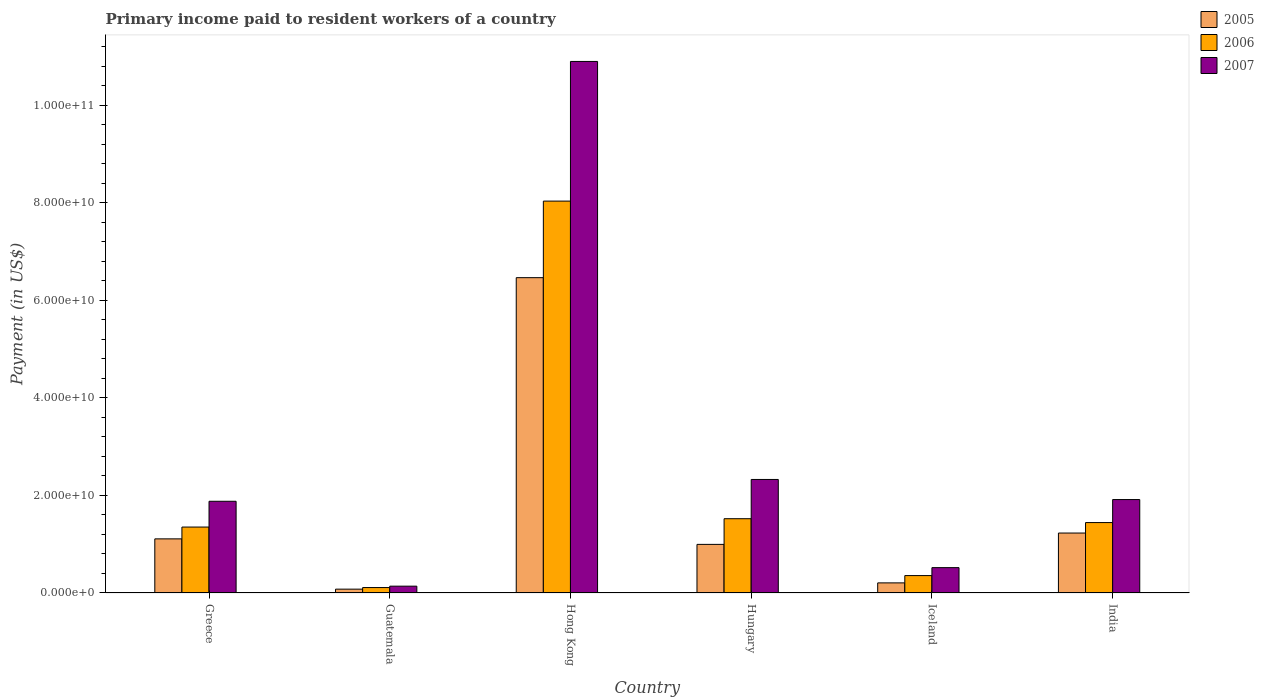How many different coloured bars are there?
Make the answer very short. 3. Are the number of bars on each tick of the X-axis equal?
Provide a succinct answer. Yes. What is the label of the 5th group of bars from the left?
Make the answer very short. Iceland. In how many cases, is the number of bars for a given country not equal to the number of legend labels?
Provide a succinct answer. 0. What is the amount paid to workers in 2006 in Guatemala?
Offer a very short reply. 1.12e+09. Across all countries, what is the maximum amount paid to workers in 2007?
Ensure brevity in your answer.  1.09e+11. Across all countries, what is the minimum amount paid to workers in 2005?
Provide a succinct answer. 7.86e+08. In which country was the amount paid to workers in 2005 maximum?
Give a very brief answer. Hong Kong. In which country was the amount paid to workers in 2005 minimum?
Offer a terse response. Guatemala. What is the total amount paid to workers in 2007 in the graph?
Your response must be concise. 1.77e+11. What is the difference between the amount paid to workers in 2007 in Greece and that in Hong Kong?
Your answer should be compact. -9.02e+1. What is the difference between the amount paid to workers in 2005 in Iceland and the amount paid to workers in 2007 in Greece?
Offer a terse response. -1.67e+1. What is the average amount paid to workers in 2007 per country?
Your response must be concise. 2.95e+1. What is the difference between the amount paid to workers of/in 2007 and amount paid to workers of/in 2005 in Guatemala?
Keep it short and to the point. 6.12e+08. What is the ratio of the amount paid to workers in 2007 in Guatemala to that in India?
Keep it short and to the point. 0.07. Is the amount paid to workers in 2006 in Guatemala less than that in Iceland?
Your answer should be very brief. Yes. Is the difference between the amount paid to workers in 2007 in Hong Kong and Hungary greater than the difference between the amount paid to workers in 2005 in Hong Kong and Hungary?
Provide a succinct answer. Yes. What is the difference between the highest and the second highest amount paid to workers in 2005?
Give a very brief answer. 5.36e+1. What is the difference between the highest and the lowest amount paid to workers in 2006?
Give a very brief answer. 7.93e+1. How many bars are there?
Your answer should be very brief. 18. How many countries are there in the graph?
Your answer should be very brief. 6. Does the graph contain any zero values?
Provide a succinct answer. No. Does the graph contain grids?
Your response must be concise. No. How are the legend labels stacked?
Make the answer very short. Vertical. What is the title of the graph?
Provide a succinct answer. Primary income paid to resident workers of a country. What is the label or title of the X-axis?
Offer a terse response. Country. What is the label or title of the Y-axis?
Keep it short and to the point. Payment (in US$). What is the Payment (in US$) in 2005 in Greece?
Keep it short and to the point. 1.11e+1. What is the Payment (in US$) in 2006 in Greece?
Your answer should be compact. 1.35e+1. What is the Payment (in US$) in 2007 in Greece?
Provide a short and direct response. 1.88e+1. What is the Payment (in US$) of 2005 in Guatemala?
Offer a terse response. 7.86e+08. What is the Payment (in US$) in 2006 in Guatemala?
Keep it short and to the point. 1.12e+09. What is the Payment (in US$) in 2007 in Guatemala?
Your response must be concise. 1.40e+09. What is the Payment (in US$) of 2005 in Hong Kong?
Provide a succinct answer. 6.47e+1. What is the Payment (in US$) of 2006 in Hong Kong?
Give a very brief answer. 8.04e+1. What is the Payment (in US$) in 2007 in Hong Kong?
Your answer should be compact. 1.09e+11. What is the Payment (in US$) in 2005 in Hungary?
Offer a very short reply. 9.97e+09. What is the Payment (in US$) of 2006 in Hungary?
Your response must be concise. 1.52e+1. What is the Payment (in US$) of 2007 in Hungary?
Give a very brief answer. 2.33e+1. What is the Payment (in US$) in 2005 in Iceland?
Your answer should be compact. 2.07e+09. What is the Payment (in US$) of 2006 in Iceland?
Provide a succinct answer. 3.57e+09. What is the Payment (in US$) in 2007 in Iceland?
Your response must be concise. 5.20e+09. What is the Payment (in US$) of 2005 in India?
Provide a short and direct response. 1.23e+1. What is the Payment (in US$) in 2006 in India?
Make the answer very short. 1.44e+1. What is the Payment (in US$) in 2007 in India?
Your answer should be compact. 1.92e+1. Across all countries, what is the maximum Payment (in US$) in 2005?
Your answer should be compact. 6.47e+1. Across all countries, what is the maximum Payment (in US$) in 2006?
Your answer should be compact. 8.04e+1. Across all countries, what is the maximum Payment (in US$) in 2007?
Give a very brief answer. 1.09e+11. Across all countries, what is the minimum Payment (in US$) of 2005?
Make the answer very short. 7.86e+08. Across all countries, what is the minimum Payment (in US$) of 2006?
Provide a short and direct response. 1.12e+09. Across all countries, what is the minimum Payment (in US$) in 2007?
Give a very brief answer. 1.40e+09. What is the total Payment (in US$) in 2005 in the graph?
Your answer should be compact. 1.01e+11. What is the total Payment (in US$) in 2006 in the graph?
Give a very brief answer. 1.28e+11. What is the total Payment (in US$) of 2007 in the graph?
Your answer should be compact. 1.77e+11. What is the difference between the Payment (in US$) in 2005 in Greece and that in Guatemala?
Your answer should be compact. 1.03e+1. What is the difference between the Payment (in US$) in 2006 in Greece and that in Guatemala?
Your answer should be compact. 1.24e+1. What is the difference between the Payment (in US$) in 2007 in Greece and that in Guatemala?
Offer a terse response. 1.74e+1. What is the difference between the Payment (in US$) of 2005 in Greece and that in Hong Kong?
Make the answer very short. -5.36e+1. What is the difference between the Payment (in US$) of 2006 in Greece and that in Hong Kong?
Provide a succinct answer. -6.69e+1. What is the difference between the Payment (in US$) of 2007 in Greece and that in Hong Kong?
Your answer should be compact. -9.02e+1. What is the difference between the Payment (in US$) in 2005 in Greece and that in Hungary?
Keep it short and to the point. 1.13e+09. What is the difference between the Payment (in US$) of 2006 in Greece and that in Hungary?
Offer a very short reply. -1.71e+09. What is the difference between the Payment (in US$) of 2007 in Greece and that in Hungary?
Your answer should be compact. -4.47e+09. What is the difference between the Payment (in US$) of 2005 in Greece and that in Iceland?
Your answer should be very brief. 9.03e+09. What is the difference between the Payment (in US$) in 2006 in Greece and that in Iceland?
Give a very brief answer. 9.95e+09. What is the difference between the Payment (in US$) in 2007 in Greece and that in Iceland?
Provide a short and direct response. 1.36e+1. What is the difference between the Payment (in US$) in 2005 in Greece and that in India?
Provide a short and direct response. -1.19e+09. What is the difference between the Payment (in US$) in 2006 in Greece and that in India?
Your response must be concise. -9.21e+08. What is the difference between the Payment (in US$) in 2007 in Greece and that in India?
Provide a succinct answer. -3.52e+08. What is the difference between the Payment (in US$) of 2005 in Guatemala and that in Hong Kong?
Your response must be concise. -6.39e+1. What is the difference between the Payment (in US$) of 2006 in Guatemala and that in Hong Kong?
Your answer should be compact. -7.93e+1. What is the difference between the Payment (in US$) in 2007 in Guatemala and that in Hong Kong?
Your response must be concise. -1.08e+11. What is the difference between the Payment (in US$) of 2005 in Guatemala and that in Hungary?
Keep it short and to the point. -9.18e+09. What is the difference between the Payment (in US$) in 2006 in Guatemala and that in Hungary?
Provide a succinct answer. -1.41e+1. What is the difference between the Payment (in US$) in 2007 in Guatemala and that in Hungary?
Offer a very short reply. -2.19e+1. What is the difference between the Payment (in US$) in 2005 in Guatemala and that in Iceland?
Your answer should be compact. -1.29e+09. What is the difference between the Payment (in US$) of 2006 in Guatemala and that in Iceland?
Your answer should be compact. -2.45e+09. What is the difference between the Payment (in US$) in 2007 in Guatemala and that in Iceland?
Your answer should be very brief. -3.80e+09. What is the difference between the Payment (in US$) in 2005 in Guatemala and that in India?
Keep it short and to the point. -1.15e+1. What is the difference between the Payment (in US$) in 2006 in Guatemala and that in India?
Your answer should be very brief. -1.33e+1. What is the difference between the Payment (in US$) of 2007 in Guatemala and that in India?
Offer a terse response. -1.78e+1. What is the difference between the Payment (in US$) in 2005 in Hong Kong and that in Hungary?
Make the answer very short. 5.47e+1. What is the difference between the Payment (in US$) in 2006 in Hong Kong and that in Hungary?
Your response must be concise. 6.51e+1. What is the difference between the Payment (in US$) in 2007 in Hong Kong and that in Hungary?
Provide a succinct answer. 8.57e+1. What is the difference between the Payment (in US$) of 2005 in Hong Kong and that in Iceland?
Make the answer very short. 6.26e+1. What is the difference between the Payment (in US$) of 2006 in Hong Kong and that in Iceland?
Provide a succinct answer. 7.68e+1. What is the difference between the Payment (in US$) in 2007 in Hong Kong and that in Iceland?
Keep it short and to the point. 1.04e+11. What is the difference between the Payment (in US$) in 2005 in Hong Kong and that in India?
Give a very brief answer. 5.24e+1. What is the difference between the Payment (in US$) of 2006 in Hong Kong and that in India?
Ensure brevity in your answer.  6.59e+1. What is the difference between the Payment (in US$) of 2007 in Hong Kong and that in India?
Your answer should be very brief. 8.99e+1. What is the difference between the Payment (in US$) in 2005 in Hungary and that in Iceland?
Give a very brief answer. 7.90e+09. What is the difference between the Payment (in US$) of 2006 in Hungary and that in Iceland?
Your response must be concise. 1.17e+1. What is the difference between the Payment (in US$) in 2007 in Hungary and that in Iceland?
Offer a very short reply. 1.81e+1. What is the difference between the Payment (in US$) in 2005 in Hungary and that in India?
Ensure brevity in your answer.  -2.33e+09. What is the difference between the Payment (in US$) of 2006 in Hungary and that in India?
Provide a short and direct response. 7.92e+08. What is the difference between the Payment (in US$) of 2007 in Hungary and that in India?
Your response must be concise. 4.12e+09. What is the difference between the Payment (in US$) of 2005 in Iceland and that in India?
Your response must be concise. -1.02e+1. What is the difference between the Payment (in US$) of 2006 in Iceland and that in India?
Your answer should be very brief. -1.09e+1. What is the difference between the Payment (in US$) of 2007 in Iceland and that in India?
Provide a short and direct response. -1.40e+1. What is the difference between the Payment (in US$) in 2005 in Greece and the Payment (in US$) in 2006 in Guatemala?
Your answer should be very brief. 9.99e+09. What is the difference between the Payment (in US$) in 2005 in Greece and the Payment (in US$) in 2007 in Guatemala?
Provide a short and direct response. 9.70e+09. What is the difference between the Payment (in US$) in 2006 in Greece and the Payment (in US$) in 2007 in Guatemala?
Your answer should be very brief. 1.21e+1. What is the difference between the Payment (in US$) in 2005 in Greece and the Payment (in US$) in 2006 in Hong Kong?
Provide a succinct answer. -6.93e+1. What is the difference between the Payment (in US$) in 2005 in Greece and the Payment (in US$) in 2007 in Hong Kong?
Keep it short and to the point. -9.79e+1. What is the difference between the Payment (in US$) of 2006 in Greece and the Payment (in US$) of 2007 in Hong Kong?
Your answer should be very brief. -9.55e+1. What is the difference between the Payment (in US$) in 2005 in Greece and the Payment (in US$) in 2006 in Hungary?
Your answer should be very brief. -4.14e+09. What is the difference between the Payment (in US$) of 2005 in Greece and the Payment (in US$) of 2007 in Hungary?
Offer a very short reply. -1.22e+1. What is the difference between the Payment (in US$) in 2006 in Greece and the Payment (in US$) in 2007 in Hungary?
Make the answer very short. -9.76e+09. What is the difference between the Payment (in US$) in 2005 in Greece and the Payment (in US$) in 2006 in Iceland?
Provide a short and direct response. 7.53e+09. What is the difference between the Payment (in US$) in 2005 in Greece and the Payment (in US$) in 2007 in Iceland?
Provide a short and direct response. 5.90e+09. What is the difference between the Payment (in US$) of 2006 in Greece and the Payment (in US$) of 2007 in Iceland?
Your answer should be compact. 8.32e+09. What is the difference between the Payment (in US$) of 2005 in Greece and the Payment (in US$) of 2006 in India?
Ensure brevity in your answer.  -3.34e+09. What is the difference between the Payment (in US$) in 2005 in Greece and the Payment (in US$) in 2007 in India?
Give a very brief answer. -8.06e+09. What is the difference between the Payment (in US$) of 2006 in Greece and the Payment (in US$) of 2007 in India?
Your answer should be very brief. -5.64e+09. What is the difference between the Payment (in US$) in 2005 in Guatemala and the Payment (in US$) in 2006 in Hong Kong?
Make the answer very short. -7.96e+1. What is the difference between the Payment (in US$) in 2005 in Guatemala and the Payment (in US$) in 2007 in Hong Kong?
Keep it short and to the point. -1.08e+11. What is the difference between the Payment (in US$) of 2006 in Guatemala and the Payment (in US$) of 2007 in Hong Kong?
Your response must be concise. -1.08e+11. What is the difference between the Payment (in US$) of 2005 in Guatemala and the Payment (in US$) of 2006 in Hungary?
Give a very brief answer. -1.45e+1. What is the difference between the Payment (in US$) in 2005 in Guatemala and the Payment (in US$) in 2007 in Hungary?
Offer a terse response. -2.25e+1. What is the difference between the Payment (in US$) in 2006 in Guatemala and the Payment (in US$) in 2007 in Hungary?
Make the answer very short. -2.22e+1. What is the difference between the Payment (in US$) of 2005 in Guatemala and the Payment (in US$) of 2006 in Iceland?
Your response must be concise. -2.78e+09. What is the difference between the Payment (in US$) of 2005 in Guatemala and the Payment (in US$) of 2007 in Iceland?
Provide a short and direct response. -4.41e+09. What is the difference between the Payment (in US$) of 2006 in Guatemala and the Payment (in US$) of 2007 in Iceland?
Your answer should be compact. -4.08e+09. What is the difference between the Payment (in US$) in 2005 in Guatemala and the Payment (in US$) in 2006 in India?
Provide a succinct answer. -1.37e+1. What is the difference between the Payment (in US$) in 2005 in Guatemala and the Payment (in US$) in 2007 in India?
Ensure brevity in your answer.  -1.84e+1. What is the difference between the Payment (in US$) of 2006 in Guatemala and the Payment (in US$) of 2007 in India?
Your answer should be very brief. -1.81e+1. What is the difference between the Payment (in US$) of 2005 in Hong Kong and the Payment (in US$) of 2006 in Hungary?
Ensure brevity in your answer.  4.94e+1. What is the difference between the Payment (in US$) of 2005 in Hong Kong and the Payment (in US$) of 2007 in Hungary?
Give a very brief answer. 4.14e+1. What is the difference between the Payment (in US$) of 2006 in Hong Kong and the Payment (in US$) of 2007 in Hungary?
Your answer should be very brief. 5.71e+1. What is the difference between the Payment (in US$) of 2005 in Hong Kong and the Payment (in US$) of 2006 in Iceland?
Ensure brevity in your answer.  6.11e+1. What is the difference between the Payment (in US$) in 2005 in Hong Kong and the Payment (in US$) in 2007 in Iceland?
Offer a very short reply. 5.95e+1. What is the difference between the Payment (in US$) in 2006 in Hong Kong and the Payment (in US$) in 2007 in Iceland?
Your answer should be compact. 7.52e+1. What is the difference between the Payment (in US$) in 2005 in Hong Kong and the Payment (in US$) in 2006 in India?
Ensure brevity in your answer.  5.02e+1. What is the difference between the Payment (in US$) in 2005 in Hong Kong and the Payment (in US$) in 2007 in India?
Your response must be concise. 4.55e+1. What is the difference between the Payment (in US$) in 2006 in Hong Kong and the Payment (in US$) in 2007 in India?
Offer a very short reply. 6.12e+1. What is the difference between the Payment (in US$) in 2005 in Hungary and the Payment (in US$) in 2006 in Iceland?
Ensure brevity in your answer.  6.40e+09. What is the difference between the Payment (in US$) of 2005 in Hungary and the Payment (in US$) of 2007 in Iceland?
Your answer should be very brief. 4.77e+09. What is the difference between the Payment (in US$) in 2006 in Hungary and the Payment (in US$) in 2007 in Iceland?
Your answer should be very brief. 1.00e+1. What is the difference between the Payment (in US$) of 2005 in Hungary and the Payment (in US$) of 2006 in India?
Offer a very short reply. -4.47e+09. What is the difference between the Payment (in US$) in 2005 in Hungary and the Payment (in US$) in 2007 in India?
Offer a very short reply. -9.20e+09. What is the difference between the Payment (in US$) of 2006 in Hungary and the Payment (in US$) of 2007 in India?
Make the answer very short. -3.93e+09. What is the difference between the Payment (in US$) in 2005 in Iceland and the Payment (in US$) in 2006 in India?
Provide a succinct answer. -1.24e+1. What is the difference between the Payment (in US$) of 2005 in Iceland and the Payment (in US$) of 2007 in India?
Give a very brief answer. -1.71e+1. What is the difference between the Payment (in US$) of 2006 in Iceland and the Payment (in US$) of 2007 in India?
Offer a very short reply. -1.56e+1. What is the average Payment (in US$) of 2005 per country?
Your answer should be compact. 1.68e+1. What is the average Payment (in US$) of 2006 per country?
Keep it short and to the point. 2.14e+1. What is the average Payment (in US$) of 2007 per country?
Your answer should be very brief. 2.95e+1. What is the difference between the Payment (in US$) of 2005 and Payment (in US$) of 2006 in Greece?
Your response must be concise. -2.42e+09. What is the difference between the Payment (in US$) in 2005 and Payment (in US$) in 2007 in Greece?
Provide a short and direct response. -7.71e+09. What is the difference between the Payment (in US$) of 2006 and Payment (in US$) of 2007 in Greece?
Your answer should be compact. -5.29e+09. What is the difference between the Payment (in US$) in 2005 and Payment (in US$) in 2006 in Guatemala?
Make the answer very short. -3.28e+08. What is the difference between the Payment (in US$) in 2005 and Payment (in US$) in 2007 in Guatemala?
Provide a succinct answer. -6.12e+08. What is the difference between the Payment (in US$) in 2006 and Payment (in US$) in 2007 in Guatemala?
Make the answer very short. -2.84e+08. What is the difference between the Payment (in US$) of 2005 and Payment (in US$) of 2006 in Hong Kong?
Your answer should be very brief. -1.57e+1. What is the difference between the Payment (in US$) of 2005 and Payment (in US$) of 2007 in Hong Kong?
Give a very brief answer. -4.43e+1. What is the difference between the Payment (in US$) in 2006 and Payment (in US$) in 2007 in Hong Kong?
Make the answer very short. -2.86e+1. What is the difference between the Payment (in US$) of 2005 and Payment (in US$) of 2006 in Hungary?
Offer a terse response. -5.27e+09. What is the difference between the Payment (in US$) in 2005 and Payment (in US$) in 2007 in Hungary?
Ensure brevity in your answer.  -1.33e+1. What is the difference between the Payment (in US$) of 2006 and Payment (in US$) of 2007 in Hungary?
Offer a very short reply. -8.05e+09. What is the difference between the Payment (in US$) of 2005 and Payment (in US$) of 2006 in Iceland?
Keep it short and to the point. -1.50e+09. What is the difference between the Payment (in US$) of 2005 and Payment (in US$) of 2007 in Iceland?
Provide a succinct answer. -3.13e+09. What is the difference between the Payment (in US$) of 2006 and Payment (in US$) of 2007 in Iceland?
Provide a short and direct response. -1.63e+09. What is the difference between the Payment (in US$) in 2005 and Payment (in US$) in 2006 in India?
Keep it short and to the point. -2.15e+09. What is the difference between the Payment (in US$) of 2005 and Payment (in US$) of 2007 in India?
Make the answer very short. -6.87e+09. What is the difference between the Payment (in US$) in 2006 and Payment (in US$) in 2007 in India?
Provide a short and direct response. -4.72e+09. What is the ratio of the Payment (in US$) in 2005 in Greece to that in Guatemala?
Give a very brief answer. 14.12. What is the ratio of the Payment (in US$) in 2006 in Greece to that in Guatemala?
Provide a succinct answer. 12.13. What is the ratio of the Payment (in US$) of 2007 in Greece to that in Guatemala?
Offer a very short reply. 13.45. What is the ratio of the Payment (in US$) in 2005 in Greece to that in Hong Kong?
Give a very brief answer. 0.17. What is the ratio of the Payment (in US$) of 2006 in Greece to that in Hong Kong?
Your answer should be very brief. 0.17. What is the ratio of the Payment (in US$) in 2007 in Greece to that in Hong Kong?
Your response must be concise. 0.17. What is the ratio of the Payment (in US$) in 2005 in Greece to that in Hungary?
Keep it short and to the point. 1.11. What is the ratio of the Payment (in US$) in 2006 in Greece to that in Hungary?
Ensure brevity in your answer.  0.89. What is the ratio of the Payment (in US$) of 2007 in Greece to that in Hungary?
Your response must be concise. 0.81. What is the ratio of the Payment (in US$) of 2005 in Greece to that in Iceland?
Offer a terse response. 5.35. What is the ratio of the Payment (in US$) in 2006 in Greece to that in Iceland?
Provide a succinct answer. 3.79. What is the ratio of the Payment (in US$) in 2007 in Greece to that in Iceland?
Provide a succinct answer. 3.62. What is the ratio of the Payment (in US$) in 2005 in Greece to that in India?
Provide a succinct answer. 0.9. What is the ratio of the Payment (in US$) of 2006 in Greece to that in India?
Offer a very short reply. 0.94. What is the ratio of the Payment (in US$) of 2007 in Greece to that in India?
Give a very brief answer. 0.98. What is the ratio of the Payment (in US$) in 2005 in Guatemala to that in Hong Kong?
Offer a very short reply. 0.01. What is the ratio of the Payment (in US$) of 2006 in Guatemala to that in Hong Kong?
Make the answer very short. 0.01. What is the ratio of the Payment (in US$) of 2007 in Guatemala to that in Hong Kong?
Your answer should be very brief. 0.01. What is the ratio of the Payment (in US$) of 2005 in Guatemala to that in Hungary?
Keep it short and to the point. 0.08. What is the ratio of the Payment (in US$) of 2006 in Guatemala to that in Hungary?
Offer a very short reply. 0.07. What is the ratio of the Payment (in US$) of 2007 in Guatemala to that in Hungary?
Your response must be concise. 0.06. What is the ratio of the Payment (in US$) in 2005 in Guatemala to that in Iceland?
Offer a terse response. 0.38. What is the ratio of the Payment (in US$) in 2006 in Guatemala to that in Iceland?
Give a very brief answer. 0.31. What is the ratio of the Payment (in US$) in 2007 in Guatemala to that in Iceland?
Provide a short and direct response. 0.27. What is the ratio of the Payment (in US$) in 2005 in Guatemala to that in India?
Your response must be concise. 0.06. What is the ratio of the Payment (in US$) in 2006 in Guatemala to that in India?
Ensure brevity in your answer.  0.08. What is the ratio of the Payment (in US$) of 2007 in Guatemala to that in India?
Provide a succinct answer. 0.07. What is the ratio of the Payment (in US$) in 2005 in Hong Kong to that in Hungary?
Provide a short and direct response. 6.49. What is the ratio of the Payment (in US$) in 2006 in Hong Kong to that in Hungary?
Offer a terse response. 5.28. What is the ratio of the Payment (in US$) in 2007 in Hong Kong to that in Hungary?
Your answer should be very brief. 4.68. What is the ratio of the Payment (in US$) of 2005 in Hong Kong to that in Iceland?
Your answer should be compact. 31.18. What is the ratio of the Payment (in US$) of 2006 in Hong Kong to that in Iceland?
Your answer should be very brief. 22.52. What is the ratio of the Payment (in US$) of 2007 in Hong Kong to that in Iceland?
Provide a short and direct response. 20.97. What is the ratio of the Payment (in US$) in 2005 in Hong Kong to that in India?
Keep it short and to the point. 5.26. What is the ratio of the Payment (in US$) of 2006 in Hong Kong to that in India?
Ensure brevity in your answer.  5.56. What is the ratio of the Payment (in US$) in 2007 in Hong Kong to that in India?
Your answer should be compact. 5.69. What is the ratio of the Payment (in US$) in 2005 in Hungary to that in Iceland?
Provide a succinct answer. 4.81. What is the ratio of the Payment (in US$) in 2006 in Hungary to that in Iceland?
Give a very brief answer. 4.27. What is the ratio of the Payment (in US$) in 2007 in Hungary to that in Iceland?
Offer a very short reply. 4.48. What is the ratio of the Payment (in US$) in 2005 in Hungary to that in India?
Give a very brief answer. 0.81. What is the ratio of the Payment (in US$) in 2006 in Hungary to that in India?
Make the answer very short. 1.05. What is the ratio of the Payment (in US$) of 2007 in Hungary to that in India?
Your answer should be very brief. 1.22. What is the ratio of the Payment (in US$) of 2005 in Iceland to that in India?
Offer a terse response. 0.17. What is the ratio of the Payment (in US$) of 2006 in Iceland to that in India?
Offer a terse response. 0.25. What is the ratio of the Payment (in US$) in 2007 in Iceland to that in India?
Your answer should be compact. 0.27. What is the difference between the highest and the second highest Payment (in US$) of 2005?
Keep it short and to the point. 5.24e+1. What is the difference between the highest and the second highest Payment (in US$) in 2006?
Provide a short and direct response. 6.51e+1. What is the difference between the highest and the second highest Payment (in US$) in 2007?
Keep it short and to the point. 8.57e+1. What is the difference between the highest and the lowest Payment (in US$) in 2005?
Make the answer very short. 6.39e+1. What is the difference between the highest and the lowest Payment (in US$) in 2006?
Provide a short and direct response. 7.93e+1. What is the difference between the highest and the lowest Payment (in US$) of 2007?
Provide a succinct answer. 1.08e+11. 